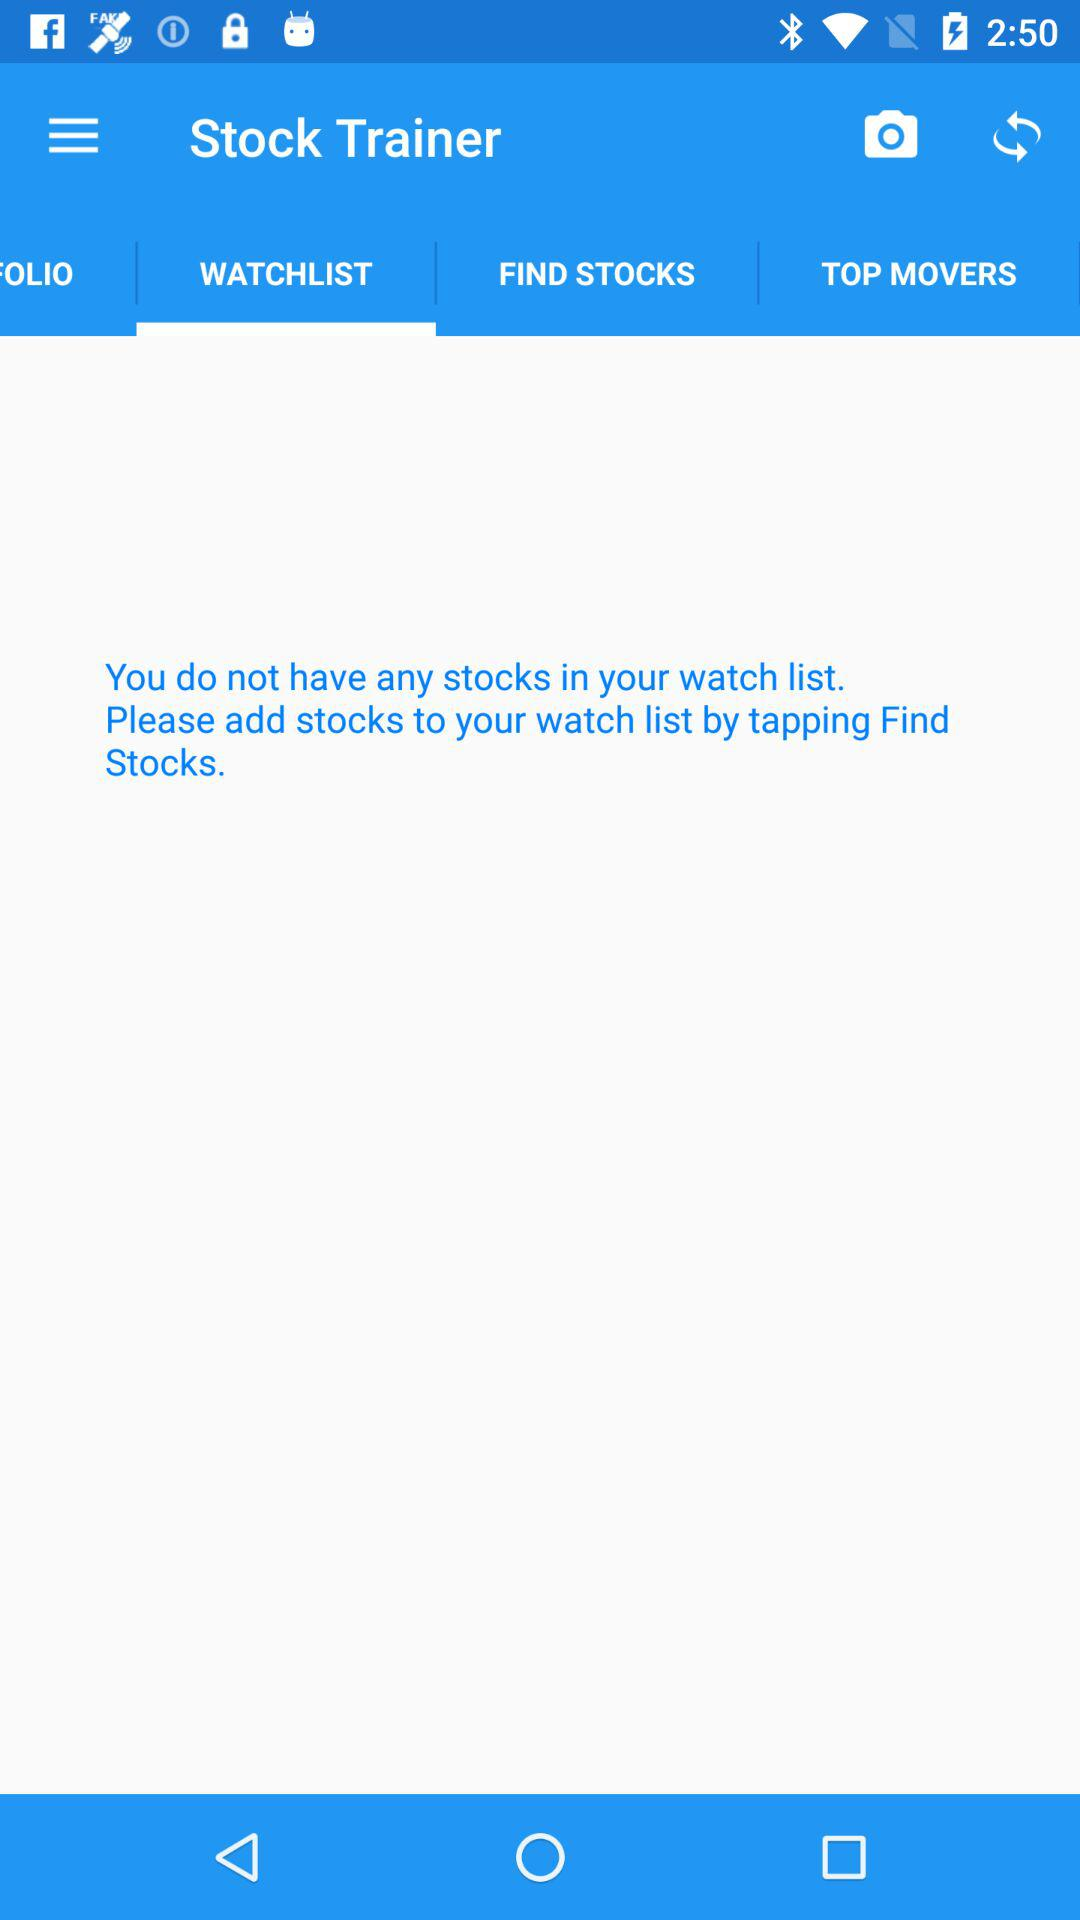Which tab is selected? The selected tab is "WATCHLIST". 